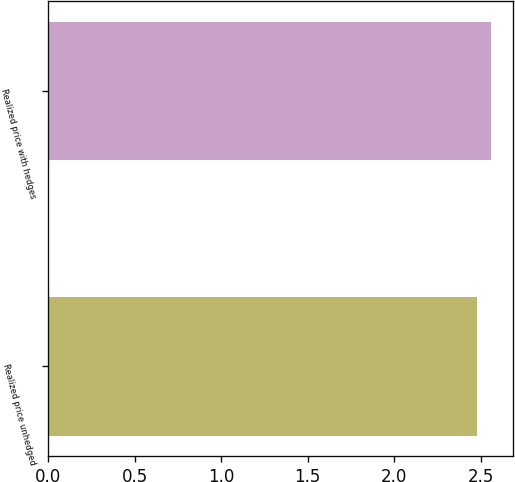Convert chart. <chart><loc_0><loc_0><loc_500><loc_500><bar_chart><fcel>Realized price unhedged<fcel>Realized price with hedges<nl><fcel>2.48<fcel>2.56<nl></chart> 